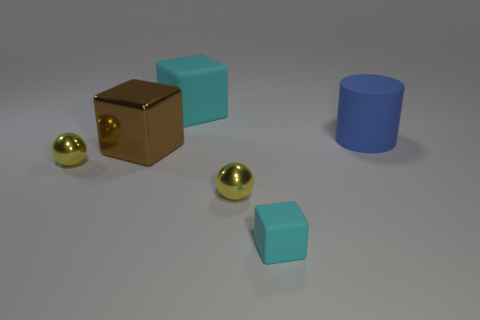Are there any small gray objects made of the same material as the big cyan block?
Your answer should be compact. No. The object that is the same color as the tiny cube is what shape?
Your answer should be compact. Cube. Are there fewer large blue objects behind the blue object than blue metal cylinders?
Offer a terse response. No. There is a cyan matte object that is behind the blue cylinder; is its size the same as the tiny cyan rubber thing?
Offer a very short reply. No. How many other tiny cyan objects are the same shape as the tiny cyan thing?
Keep it short and to the point. 0. There is a blue object that is made of the same material as the small cube; what is its size?
Ensure brevity in your answer.  Large. Is the number of blue matte things on the right side of the blue cylinder the same as the number of big red things?
Keep it short and to the point. Yes. Does the rubber cylinder have the same color as the big metallic block?
Provide a succinct answer. No. Do the shiny thing that is on the right side of the big brown block and the large thing behind the large cylinder have the same shape?
Give a very brief answer. No. There is a small object that is the same shape as the big metal object; what material is it?
Give a very brief answer. Rubber. 